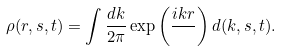<formula> <loc_0><loc_0><loc_500><loc_500>\rho ( r , s , t ) = \int \frac { d k } { 2 \pi } \exp \left ( \frac { i k r } { } \right ) d ( k , s , t ) .</formula> 